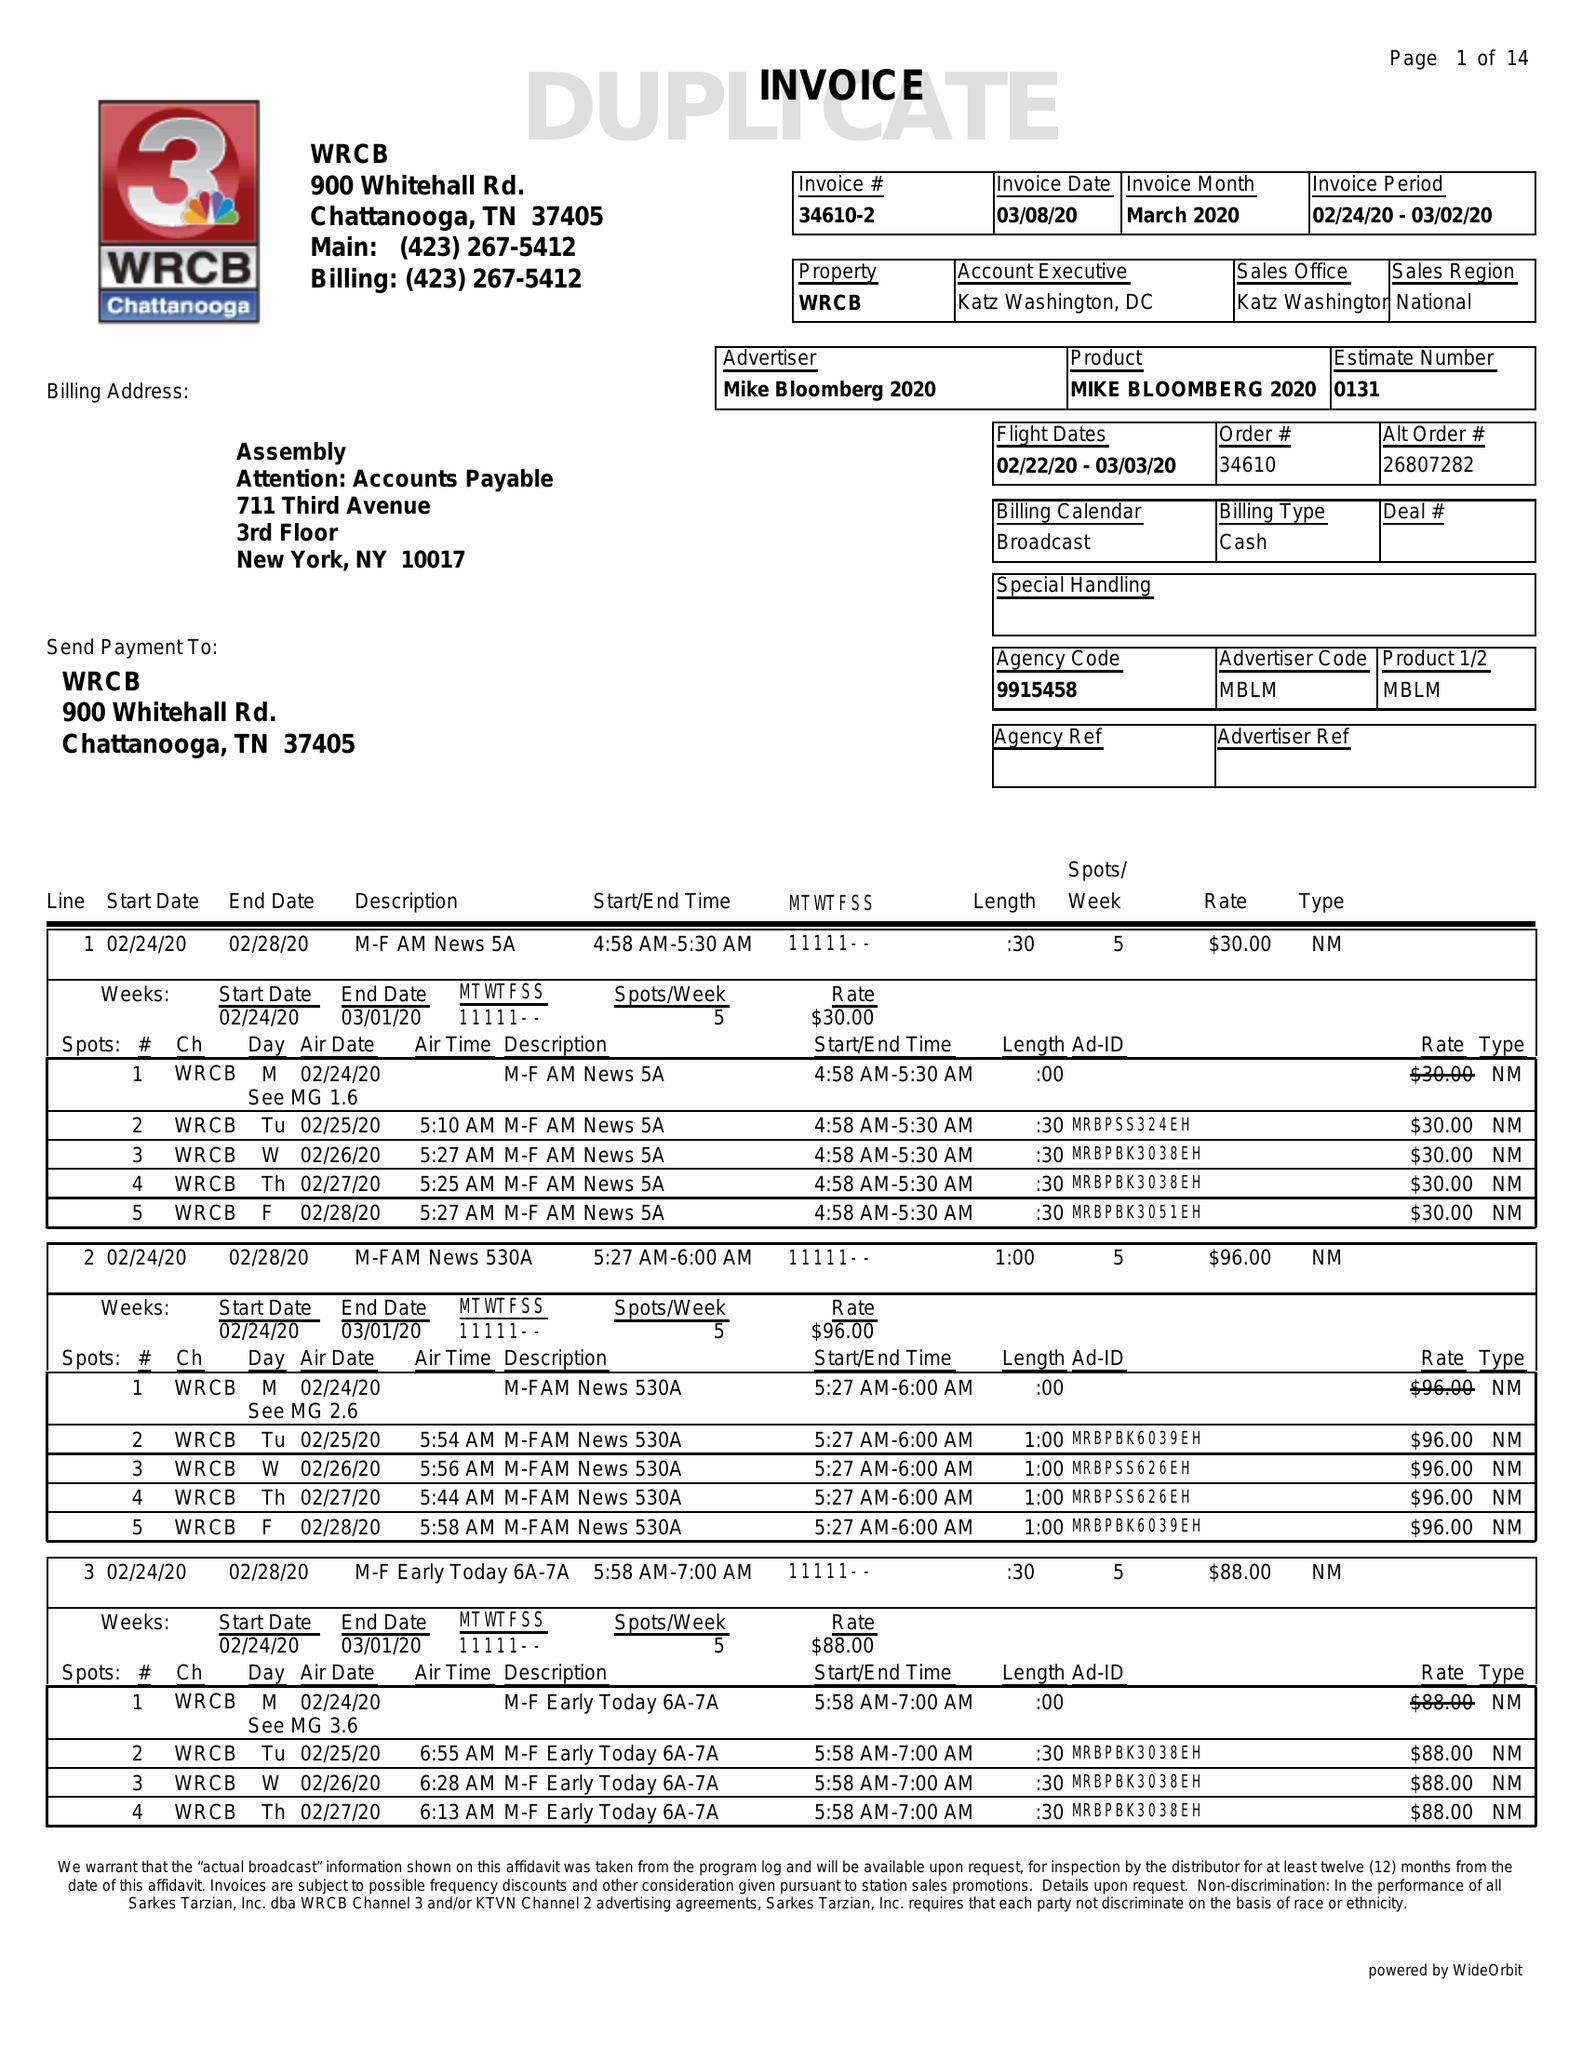What is the value for the flight_to?
Answer the question using a single word or phrase. 03/03/20 